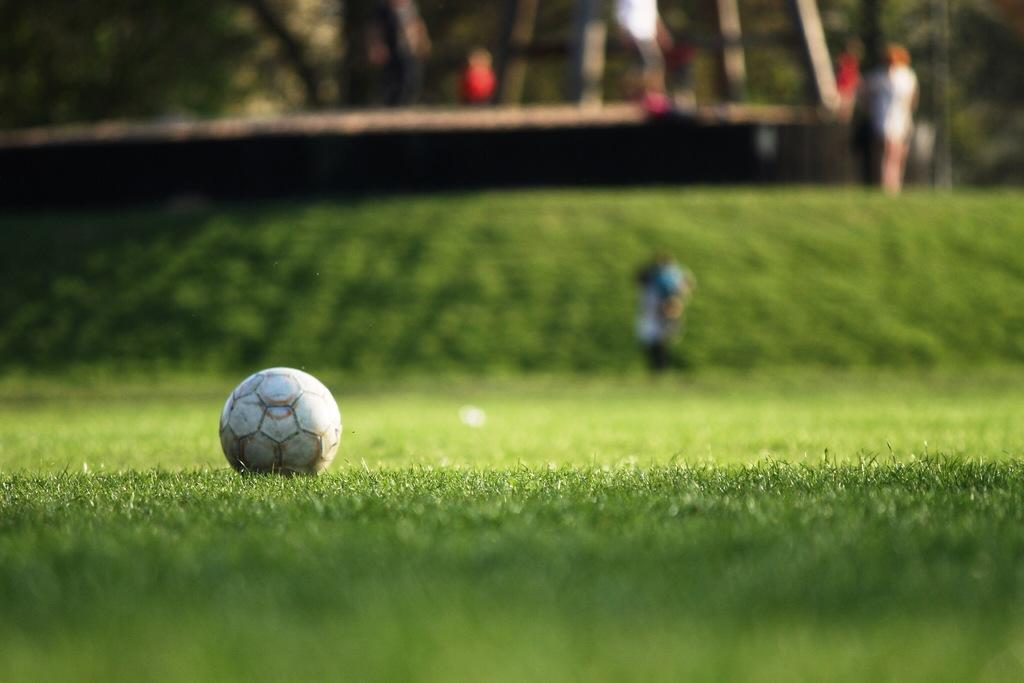What object is present in the image? There is a ball in the image. Where is the ball located? The ball is on the grass. What type of surface is the ball resting on? The grass is visible in the image. Can you describe the background of the image? The background of the image is blurred. How many cats are playing with the bone in the image? There are no cats or bones present in the image; it only features a ball on the grass with a blurred background. 